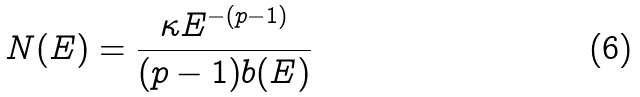Convert formula to latex. <formula><loc_0><loc_0><loc_500><loc_500>N ( E ) = \frac { \kappa E ^ { - ( p - 1 ) } } { ( p - 1 ) b ( E ) }</formula> 